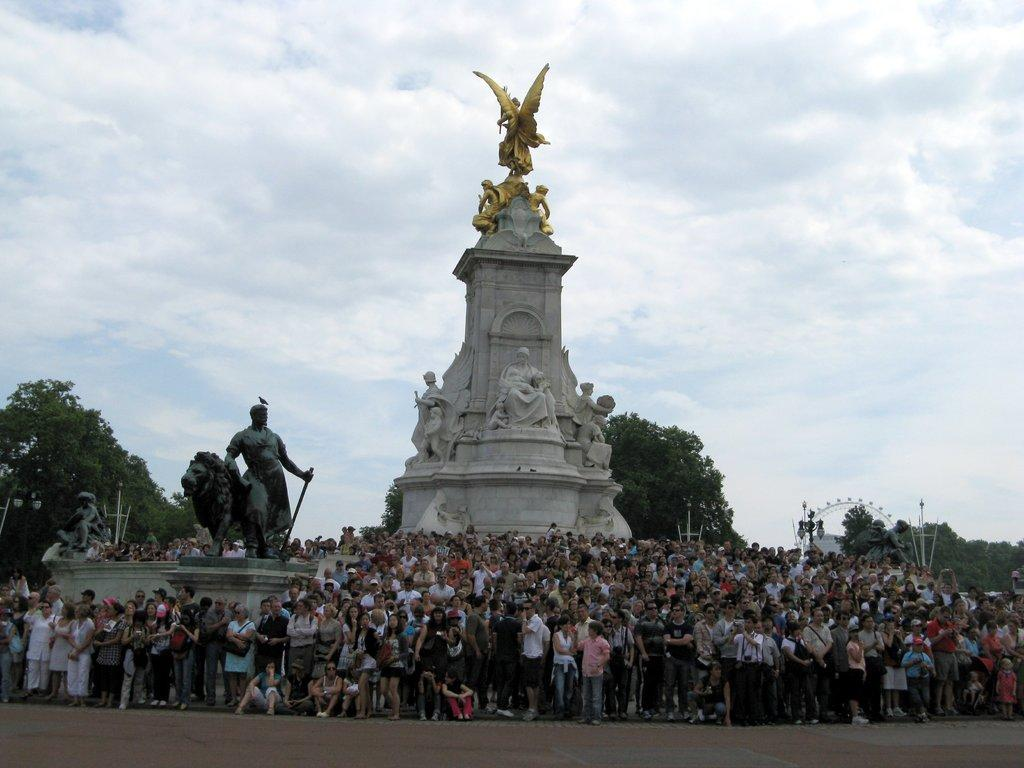What type of art can be seen in the image? There are sculptures in the image. Are there any people present in the image? Yes, there are people in the image. What other elements can be seen in the image besides sculptures and people? There are trees and light poles in the image. What is visible in the background of the image? The sky is visible in the background of the image. What type of bead is being used as an example during the meeting in the image? There is no meeting or bead present in the image. What type of meeting is taking place in the image? There is no meeting present in the image; it features sculptures, people, trees, light poles, and the sky. 